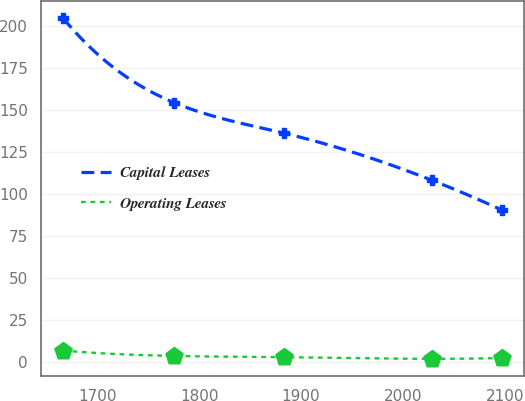<chart> <loc_0><loc_0><loc_500><loc_500><line_chart><ecel><fcel>Capital Leases<fcel>Operating Leases<nl><fcel>1666.29<fcel>204.59<fcel>6.68<nl><fcel>1775.5<fcel>154.22<fcel>3.5<nl><fcel>1883.61<fcel>136.04<fcel>2.76<nl><fcel>2028.56<fcel>108.05<fcel>1.78<nl><fcel>2097.74<fcel>90.22<fcel>2.27<nl></chart> 